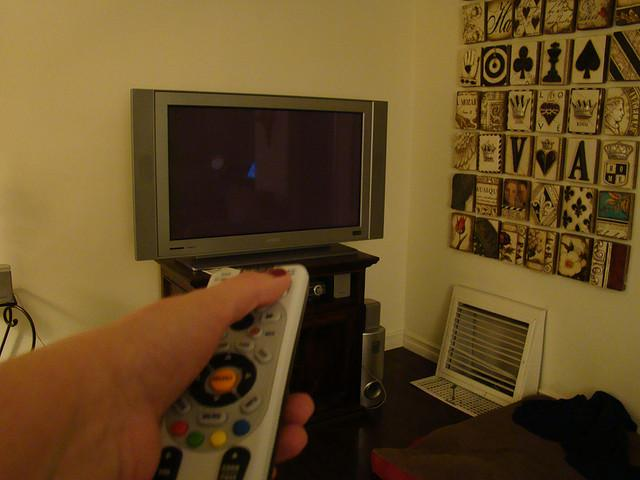What does this person want to do? Please explain your reasoning. change channel. A person is pointing a remote at a television. people use remotes to change the television channel. 